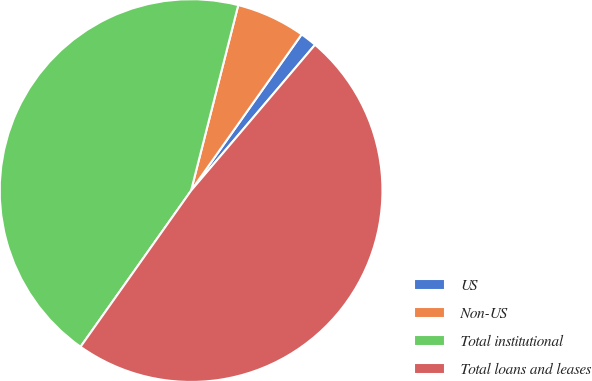<chart> <loc_0><loc_0><loc_500><loc_500><pie_chart><fcel>US<fcel>Non-US<fcel>Total institutional<fcel>Total loans and leases<nl><fcel>1.41%<fcel>5.84%<fcel>44.16%<fcel>48.59%<nl></chart> 